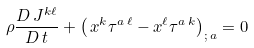<formula> <loc_0><loc_0><loc_500><loc_500>\rho \frac { D \, J ^ { k \ell } } { D \, t } + \left ( \, x ^ { k } \tau ^ { a \, \ell } - x ^ { \ell } \tau ^ { a \, k } \right ) _ { ; \, a } = 0</formula> 